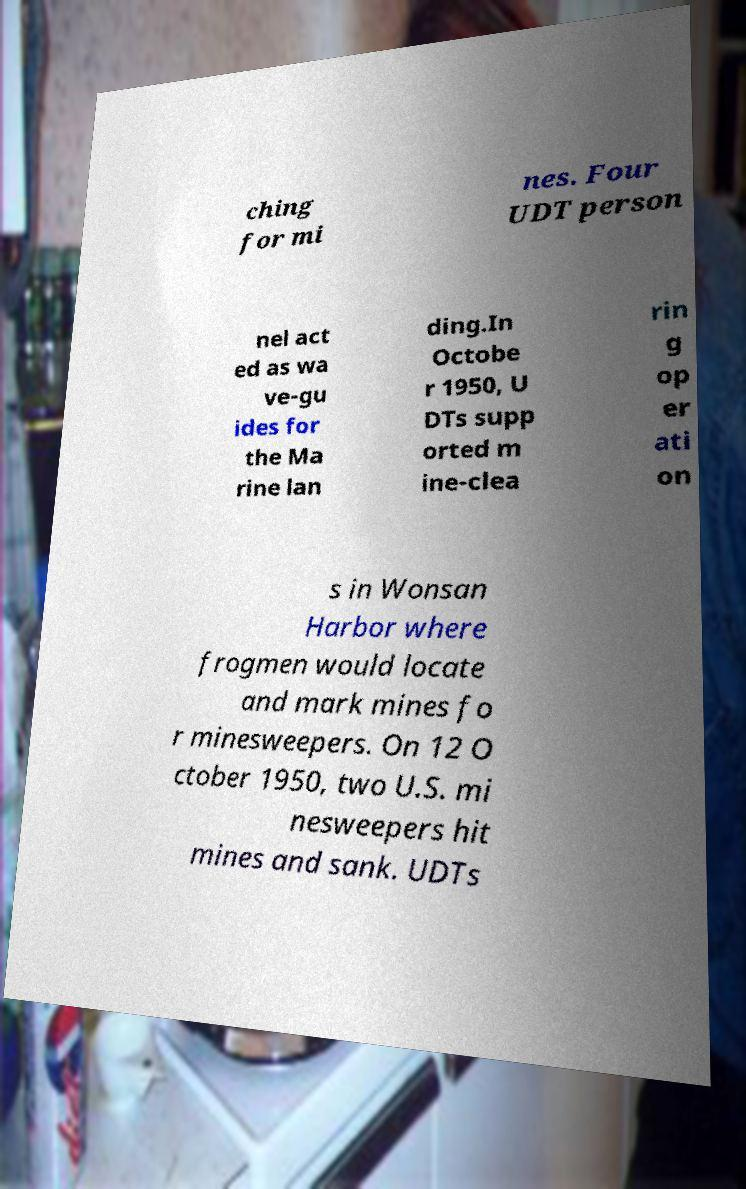I need the written content from this picture converted into text. Can you do that? ching for mi nes. Four UDT person nel act ed as wa ve-gu ides for the Ma rine lan ding.In Octobe r 1950, U DTs supp orted m ine-clea rin g op er ati on s in Wonsan Harbor where frogmen would locate and mark mines fo r minesweepers. On 12 O ctober 1950, two U.S. mi nesweepers hit mines and sank. UDTs 